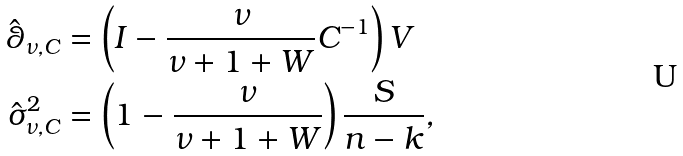<formula> <loc_0><loc_0><loc_500><loc_500>\hat { \theta } _ { \nu , C } & = \left ( I - \frac { \nu } { \nu + 1 + W } C ^ { - 1 } \right ) V \\ \hat { \sigma } ^ { 2 } _ { \nu , C } & = \left ( 1 - \frac { \nu } { \nu + 1 + W } \right ) \frac { S } { n - k } ,</formula> 